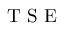<formula> <loc_0><loc_0><loc_500><loc_500>T S E</formula> 